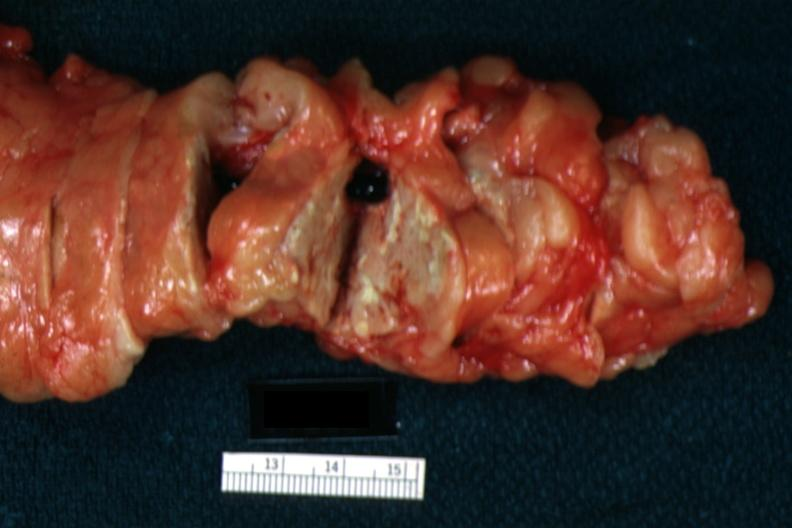how is fat necrosis seen with no parenchymal lesion?
Answer the question using a single word or phrase. Evident 